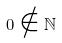<formula> <loc_0><loc_0><loc_500><loc_500>0 \notin \mathbb { N }</formula> 